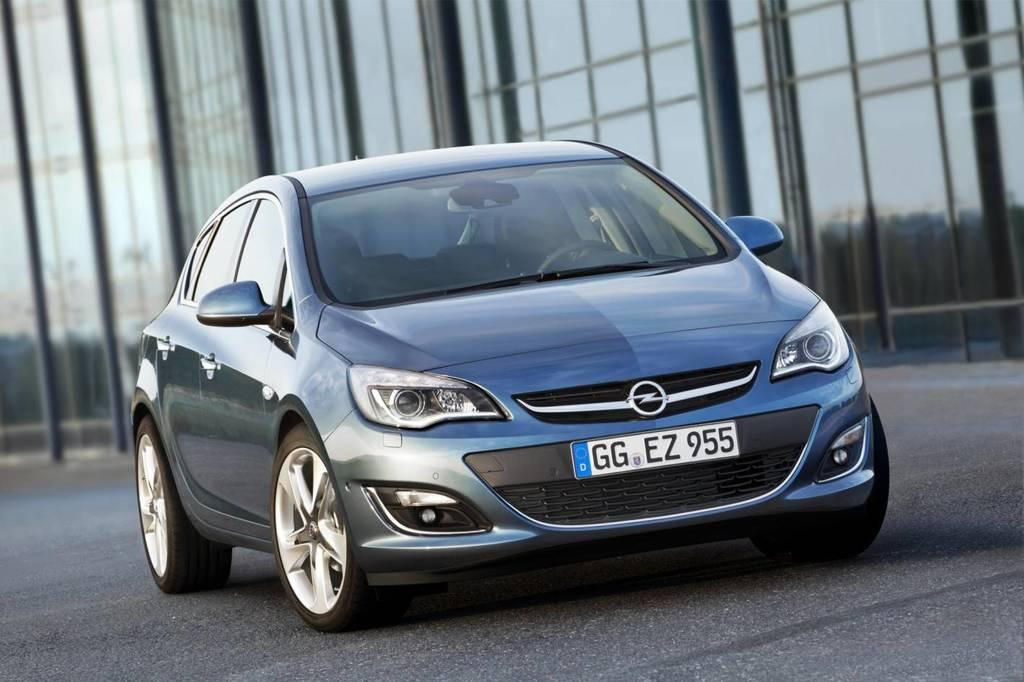What is the main subject of the image? The main subject of the image is a car. Where is the car located in the image? The car is on the road in the image. What can be seen in the background of the image? There are buildings in the background of the image. What type of clouds can be seen in the image? There are no clouds visible in the image; it only shows a car on the road and buildings in the background. 